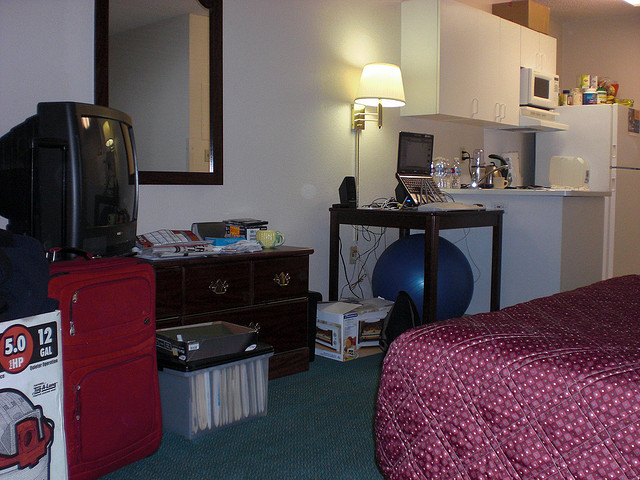Identify the text displayed in this image. 5 0 12 GAL 